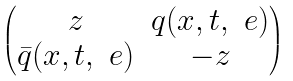Convert formula to latex. <formula><loc_0><loc_0><loc_500><loc_500>\begin{pmatrix} z & q ( x , t , \ e ) \\ \bar { q } ( x , t , \ e ) & - z \end{pmatrix}</formula> 